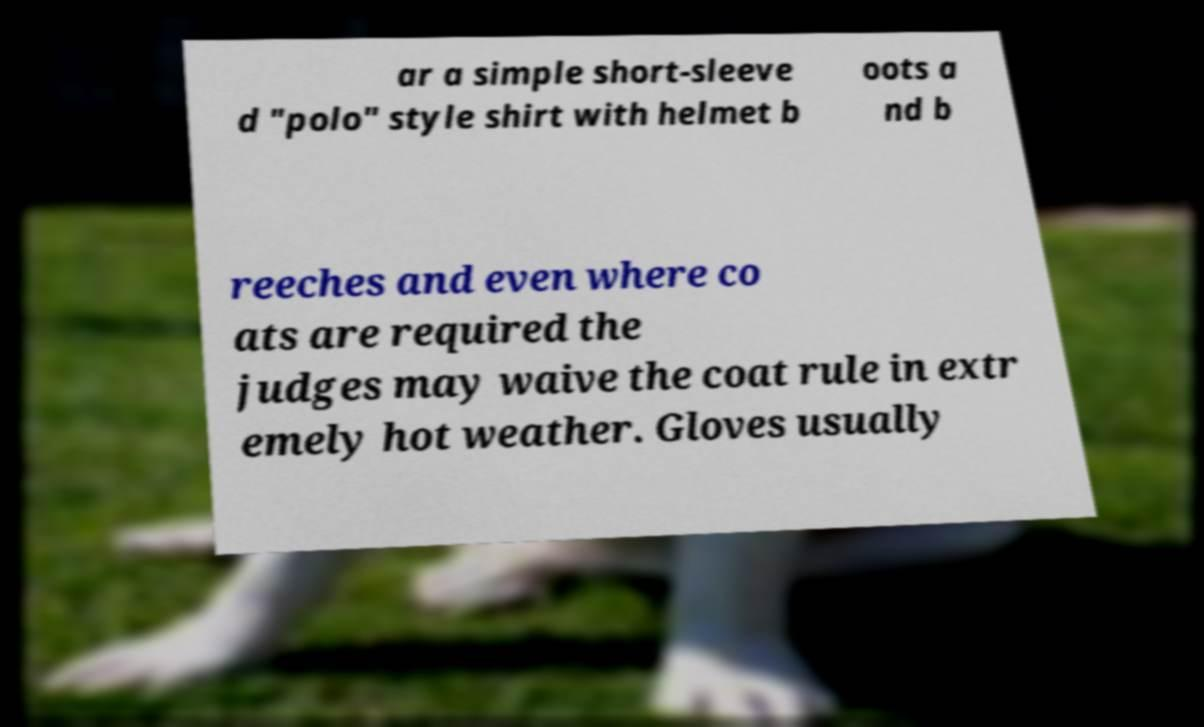Could you assist in decoding the text presented in this image and type it out clearly? ar a simple short-sleeve d "polo" style shirt with helmet b oots a nd b reeches and even where co ats are required the judges may waive the coat rule in extr emely hot weather. Gloves usually 